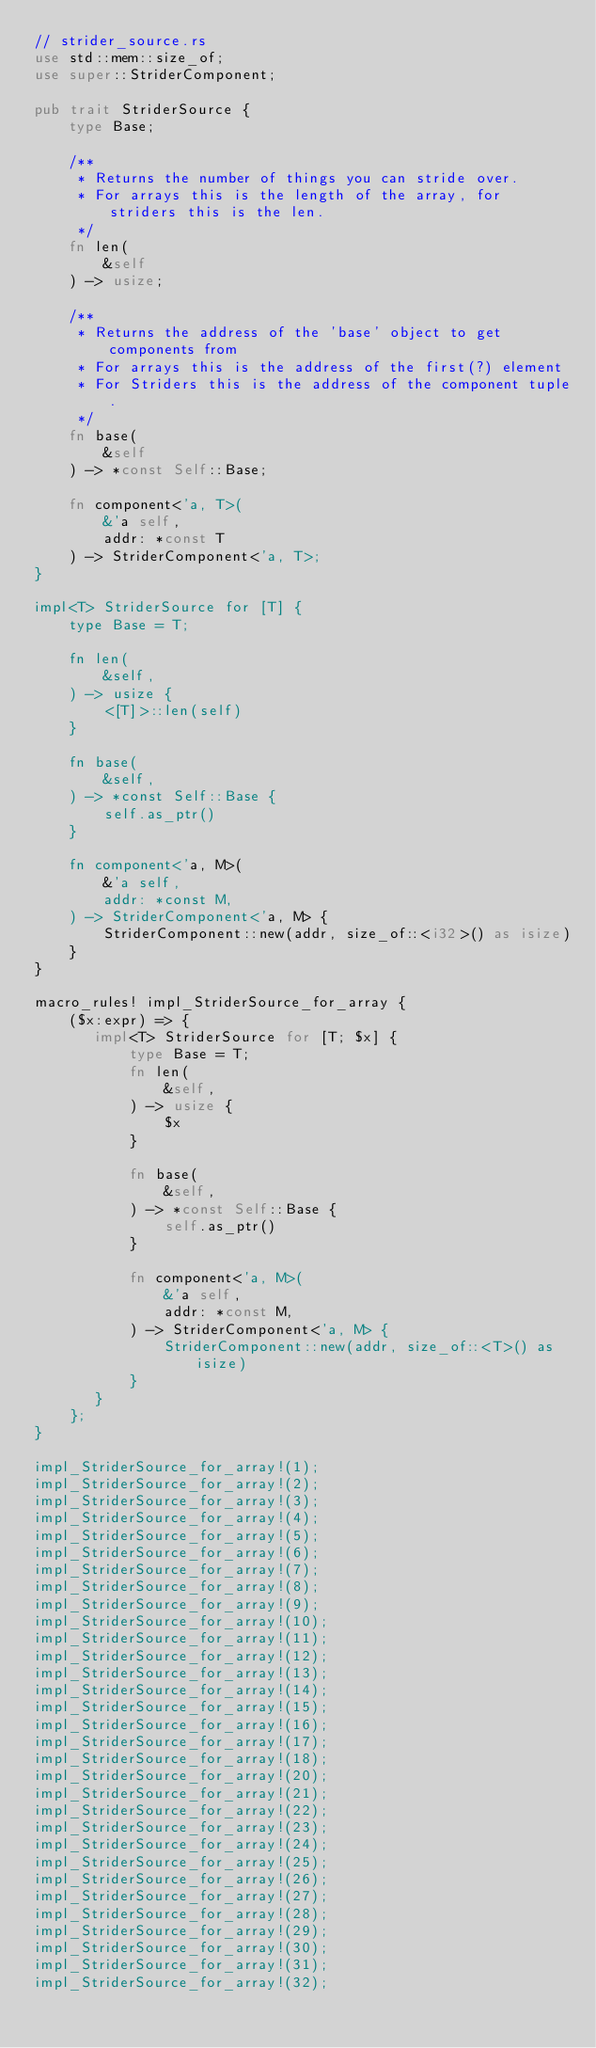<code> <loc_0><loc_0><loc_500><loc_500><_Rust_>// strider_source.rs
use std::mem::size_of;
use super::StriderComponent;

pub trait StriderSource {
    type Base;

    /**
     * Returns the number of things you can stride over.
     * For arrays this is the length of the array, for striders this is the len.
     */
    fn len(
        &self
    ) -> usize;

    /**
     * Returns the address of the 'base' object to get components from
     * For arrays this is the address of the first(?) element
     * For Striders this is the address of the component tuple.
     */
    fn base(
        &self
    ) -> *const Self::Base;

    fn component<'a, T>(
        &'a self,
        addr: *const T
    ) -> StriderComponent<'a, T>;
}

impl<T> StriderSource for [T] {
    type Base = T;

    fn len(
        &self,
    ) -> usize {
        <[T]>::len(self)
    }

    fn base(
        &self,
    ) -> *const Self::Base {
        self.as_ptr()
    }

    fn component<'a, M>(
        &'a self,
        addr: *const M,
    ) -> StriderComponent<'a, M> {
        StriderComponent::new(addr, size_of::<i32>() as isize)
    }
}

macro_rules! impl_StriderSource_for_array {
    ($x:expr) => {
       impl<T> StriderSource for [T; $x] {
           type Base = T;
           fn len(
               &self,
           ) -> usize {
               $x
           }

           fn base(
               &self,
           ) -> *const Self::Base {
               self.as_ptr()
           }

           fn component<'a, M>(
               &'a self,
               addr: *const M,
           ) -> StriderComponent<'a, M> {
               StriderComponent::new(addr, size_of::<T>() as isize)
           }
       } 
    };
}

impl_StriderSource_for_array!(1);
impl_StriderSource_for_array!(2);
impl_StriderSource_for_array!(3);
impl_StriderSource_for_array!(4);
impl_StriderSource_for_array!(5);
impl_StriderSource_for_array!(6);
impl_StriderSource_for_array!(7);
impl_StriderSource_for_array!(8);
impl_StriderSource_for_array!(9);
impl_StriderSource_for_array!(10);
impl_StriderSource_for_array!(11);
impl_StriderSource_for_array!(12);
impl_StriderSource_for_array!(13);
impl_StriderSource_for_array!(14);
impl_StriderSource_for_array!(15);
impl_StriderSource_for_array!(16);
impl_StriderSource_for_array!(17);
impl_StriderSource_for_array!(18);
impl_StriderSource_for_array!(20);
impl_StriderSource_for_array!(21);
impl_StriderSource_for_array!(22);
impl_StriderSource_for_array!(23);
impl_StriderSource_for_array!(24);
impl_StriderSource_for_array!(25);
impl_StriderSource_for_array!(26);
impl_StriderSource_for_array!(27);
impl_StriderSource_for_array!(28);
impl_StriderSource_for_array!(29);
impl_StriderSource_for_array!(30);
impl_StriderSource_for_array!(31);
impl_StriderSource_for_array!(32);
</code> 